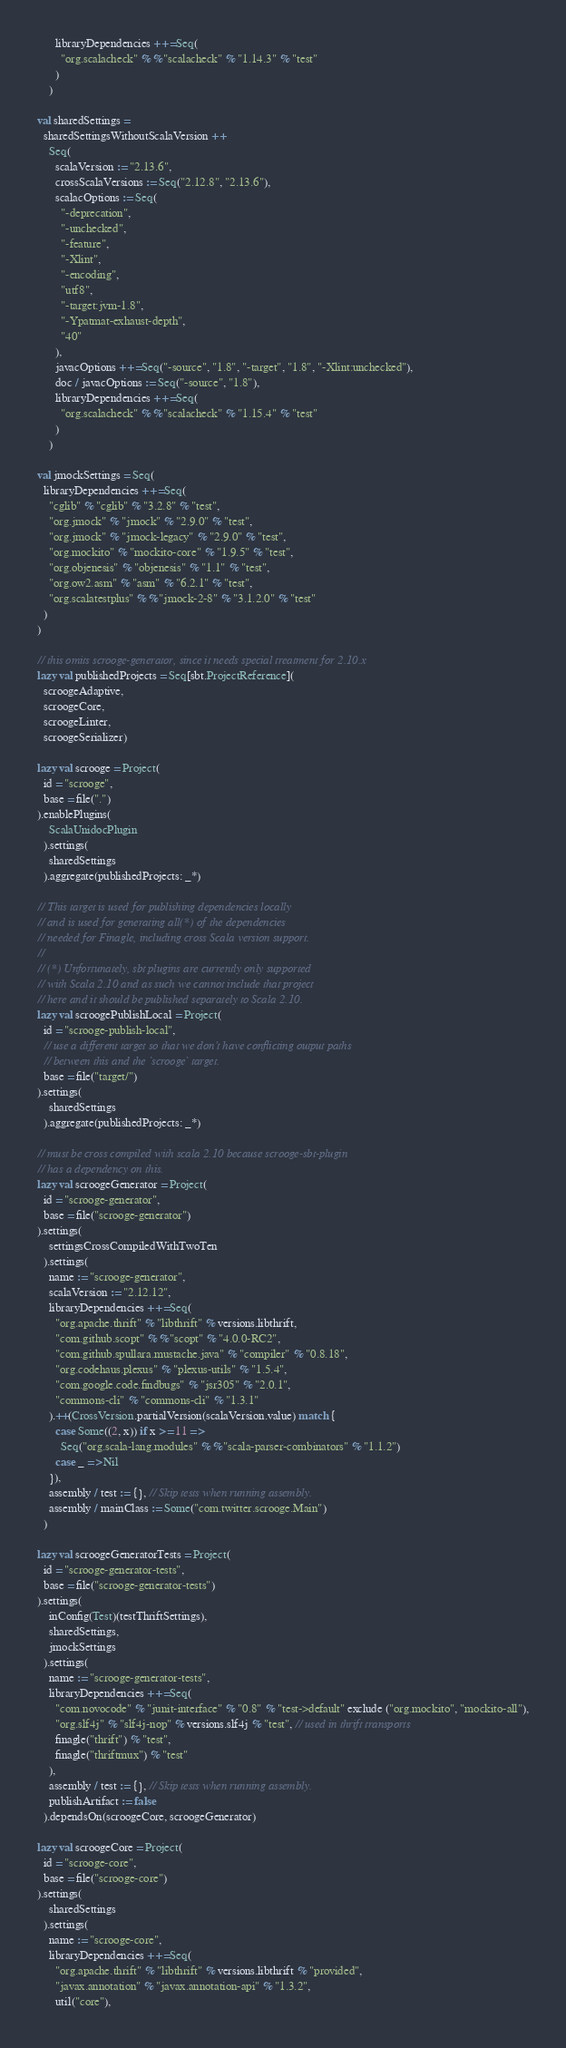<code> <loc_0><loc_0><loc_500><loc_500><_Scala_>      libraryDependencies ++= Seq(
        "org.scalacheck" %% "scalacheck" % "1.14.3" % "test"
      )
    )

val sharedSettings =
  sharedSettingsWithoutScalaVersion ++
    Seq(
      scalaVersion := "2.13.6",
      crossScalaVersions := Seq("2.12.8", "2.13.6"),
      scalacOptions := Seq(
        "-deprecation",
        "-unchecked",
        "-feature",
        "-Xlint",
        "-encoding",
        "utf8",
        "-target:jvm-1.8",
        "-Ypatmat-exhaust-depth",
        "40"
      ),
      javacOptions ++= Seq("-source", "1.8", "-target", "1.8", "-Xlint:unchecked"),
      doc / javacOptions := Seq("-source", "1.8"),
      libraryDependencies ++= Seq(
        "org.scalacheck" %% "scalacheck" % "1.15.4" % "test"
      )
    )

val jmockSettings = Seq(
  libraryDependencies ++= Seq(
    "cglib" % "cglib" % "3.2.8" % "test",
    "org.jmock" % "jmock" % "2.9.0" % "test",
    "org.jmock" % "jmock-legacy" % "2.9.0" % "test",
    "org.mockito" % "mockito-core" % "1.9.5" % "test",
    "org.objenesis" % "objenesis" % "1.1" % "test",
    "org.ow2.asm" % "asm" % "6.2.1" % "test",
    "org.scalatestplus" %% "jmock-2-8" % "3.1.2.0" % "test"
  )
)

// this omits scrooge-generator, since it needs special treatment for 2.10.x
lazy val publishedProjects = Seq[sbt.ProjectReference](
  scroogeAdaptive,
  scroogeCore,
  scroogeLinter,
  scroogeSerializer)

lazy val scrooge = Project(
  id = "scrooge",
  base = file(".")
).enablePlugins(
    ScalaUnidocPlugin
  ).settings(
    sharedSettings
  ).aggregate(publishedProjects: _*)

// This target is used for publishing dependencies locally
// and is used for generating all(*) of the dependencies
// needed for Finagle, including cross Scala version support.
//
// (*) Unfortunately, sbt plugins are currently only supported
// with Scala 2.10 and as such we cannot include that project
// here and it should be published separately to Scala 2.10.
lazy val scroogePublishLocal = Project(
  id = "scrooge-publish-local",
  // use a different target so that we don't have conflicting output paths
  // between this and the `scrooge` target.
  base = file("target/")
).settings(
    sharedSettings
  ).aggregate(publishedProjects: _*)

// must be cross compiled with scala 2.10 because scrooge-sbt-plugin
// has a dependency on this.
lazy val scroogeGenerator = Project(
  id = "scrooge-generator",
  base = file("scrooge-generator")
).settings(
    settingsCrossCompiledWithTwoTen
  ).settings(
    name := "scrooge-generator",
    scalaVersion := "2.12.12",
    libraryDependencies ++= Seq(
      "org.apache.thrift" % "libthrift" % versions.libthrift,
      "com.github.scopt" %% "scopt" % "4.0.0-RC2",
      "com.github.spullara.mustache.java" % "compiler" % "0.8.18",
      "org.codehaus.plexus" % "plexus-utils" % "1.5.4",
      "com.google.code.findbugs" % "jsr305" % "2.0.1",
      "commons-cli" % "commons-cli" % "1.3.1"
    ).++(CrossVersion.partialVersion(scalaVersion.value) match {
      case Some((2, x)) if x >= 11 =>
        Seq("org.scala-lang.modules" %% "scala-parser-combinators" % "1.1.2")
      case _ => Nil
    }),
    assembly / test := {}, // Skip tests when running assembly.
    assembly / mainClass := Some("com.twitter.scrooge.Main")
  )

lazy val scroogeGeneratorTests = Project(
  id = "scrooge-generator-tests",
  base = file("scrooge-generator-tests")
).settings(
    inConfig(Test)(testThriftSettings),
    sharedSettings,
    jmockSettings
  ).settings(
    name := "scrooge-generator-tests",
    libraryDependencies ++= Seq(
      "com.novocode" % "junit-interface" % "0.8" % "test->default" exclude ("org.mockito", "mockito-all"),
      "org.slf4j" % "slf4j-nop" % versions.slf4j % "test", // used in thrift transports
      finagle("thrift") % "test",
      finagle("thriftmux") % "test"
    ),
    assembly / test := {}, // Skip tests when running assembly.
    publishArtifact := false
  ).dependsOn(scroogeCore, scroogeGenerator)

lazy val scroogeCore = Project(
  id = "scrooge-core",
  base = file("scrooge-core")
).settings(
    sharedSettings
  ).settings(
    name := "scrooge-core",
    libraryDependencies ++= Seq(
      "org.apache.thrift" % "libthrift" % versions.libthrift % "provided",
      "javax.annotation" % "javax.annotation-api" % "1.3.2",
      util("core"),</code> 